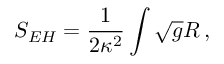<formula> <loc_0><loc_0><loc_500><loc_500>S _ { E H } = \frac { 1 } { 2 \kappa ^ { 2 } } \int \sqrt { g } R \, ,</formula> 